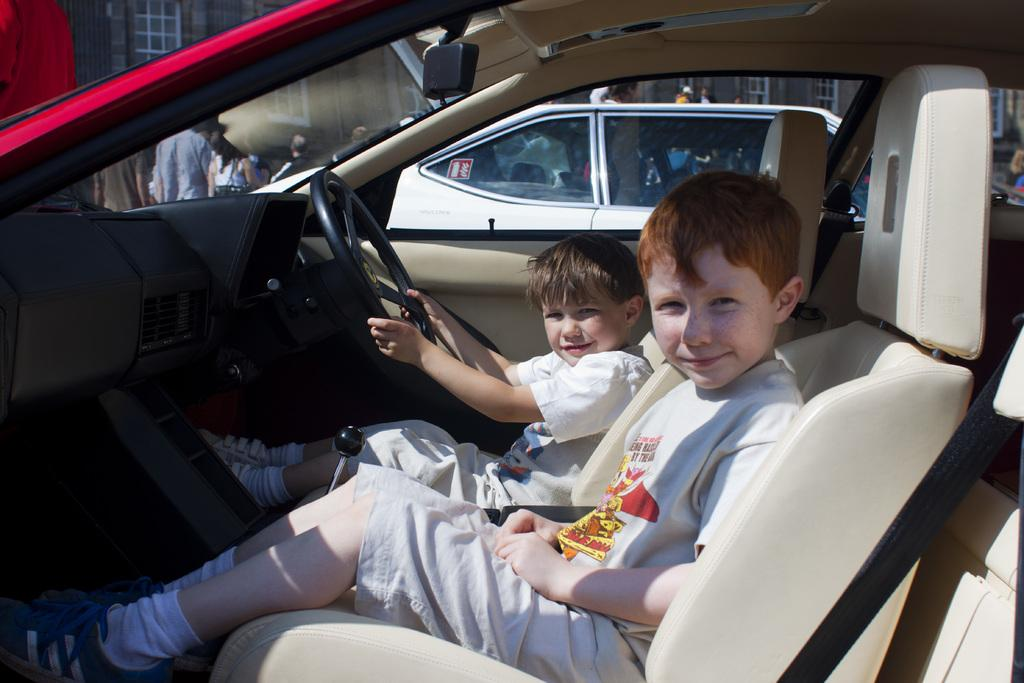Where was the image taken? The image is taken outdoors. What are the kids doing in the image? The two kids are sitting in a car. What is visible behind the kids? There is a glass window behind the kids. What is happening behind the car in the image? There is a group of people standing on the road behind the car. How many jars can be seen on the car in the image? There are no jars visible on the car in the image. Are there any bikes parked near the car in the image? There is no mention of bikes in the image; only a group of people standing on the road behind the car. 